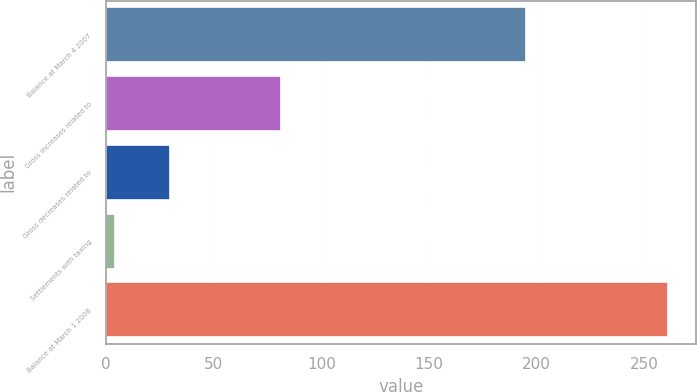<chart> <loc_0><loc_0><loc_500><loc_500><bar_chart><fcel>Balance at March 4 2007<fcel>Gross increases related to<fcel>Gross decreases related to<fcel>Settlements with taxing<fcel>Balance at March 1 2008<nl><fcel>195<fcel>81.1<fcel>29.7<fcel>4<fcel>261<nl></chart> 